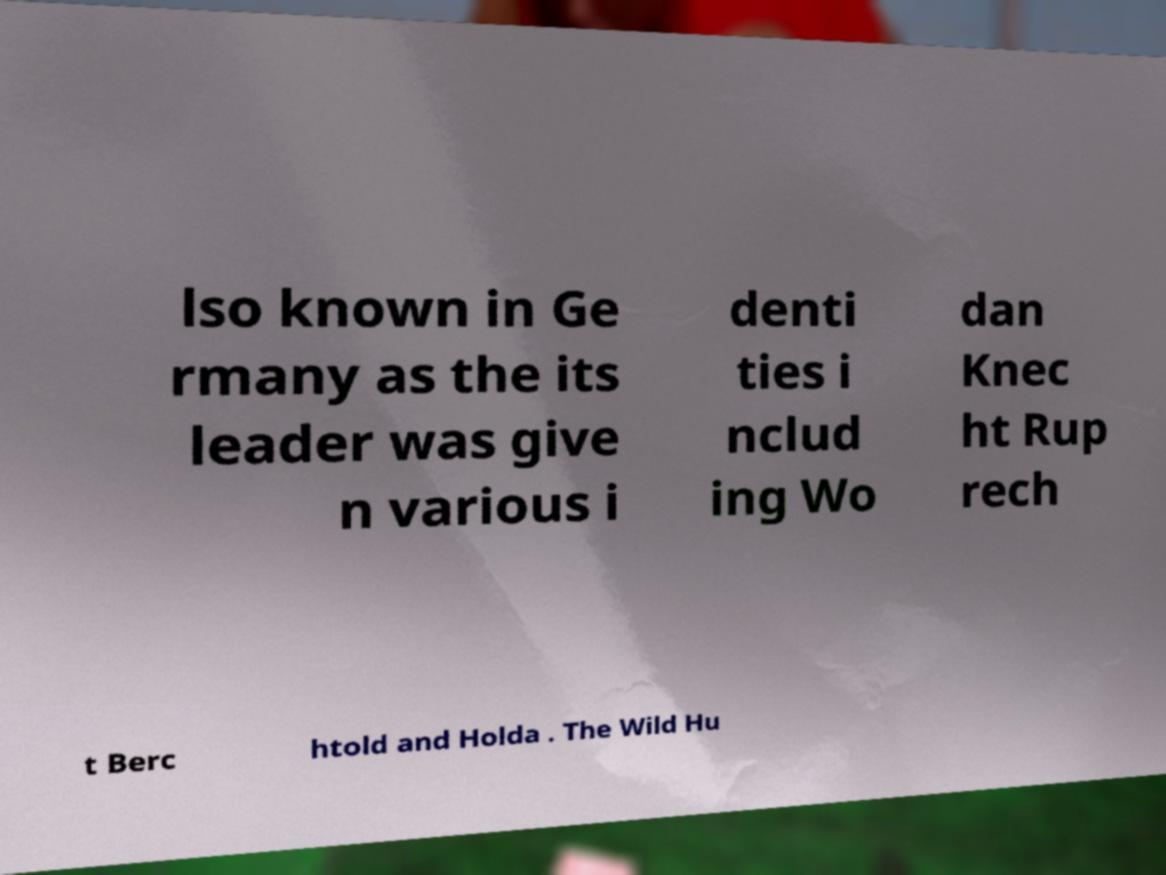Can you accurately transcribe the text from the provided image for me? lso known in Ge rmany as the its leader was give n various i denti ties i nclud ing Wo dan Knec ht Rup rech t Berc htold and Holda . The Wild Hu 